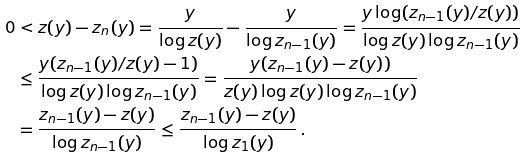Convert formula to latex. <formula><loc_0><loc_0><loc_500><loc_500>0 & < z ( y ) - z _ { n } ( y ) = \frac { y } { \log z ( y ) } - \frac { y } { \log z _ { n - 1 } ( y ) } = \frac { y \log ( z _ { n - 1 } ( y ) / z ( y ) ) } { \log z ( y ) \log z _ { n - 1 } ( y ) } \\ & \leq \frac { y ( z _ { n - 1 } ( y ) / z ( y ) - 1 ) } { \log z ( y ) \log z _ { n - 1 } ( y ) } = \frac { y ( z _ { n - 1 } ( y ) - z ( y ) ) } { z ( y ) \log z ( y ) \log z _ { n - 1 } ( y ) } \\ & = \frac { z _ { n - 1 } ( y ) - z ( y ) } { \log z _ { n - 1 } ( y ) } \leq \frac { z _ { n - 1 } ( y ) - z ( y ) } { \log z _ { 1 } ( y ) } \, .</formula> 